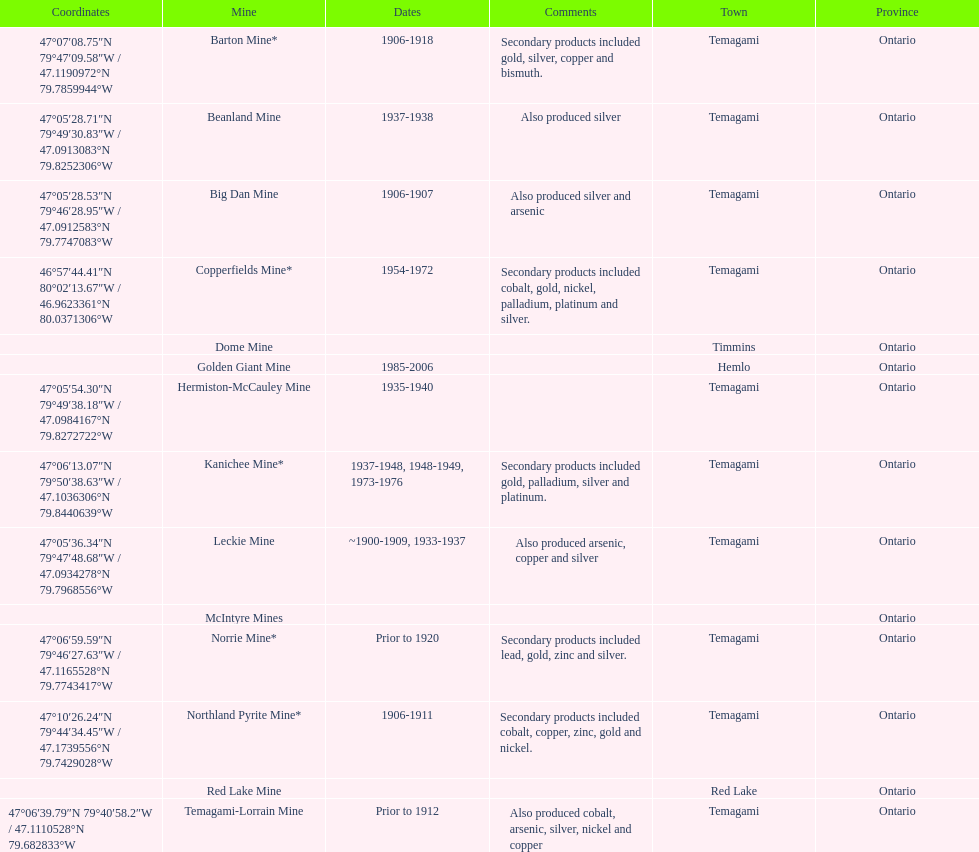How many mines were in temagami? 10. 